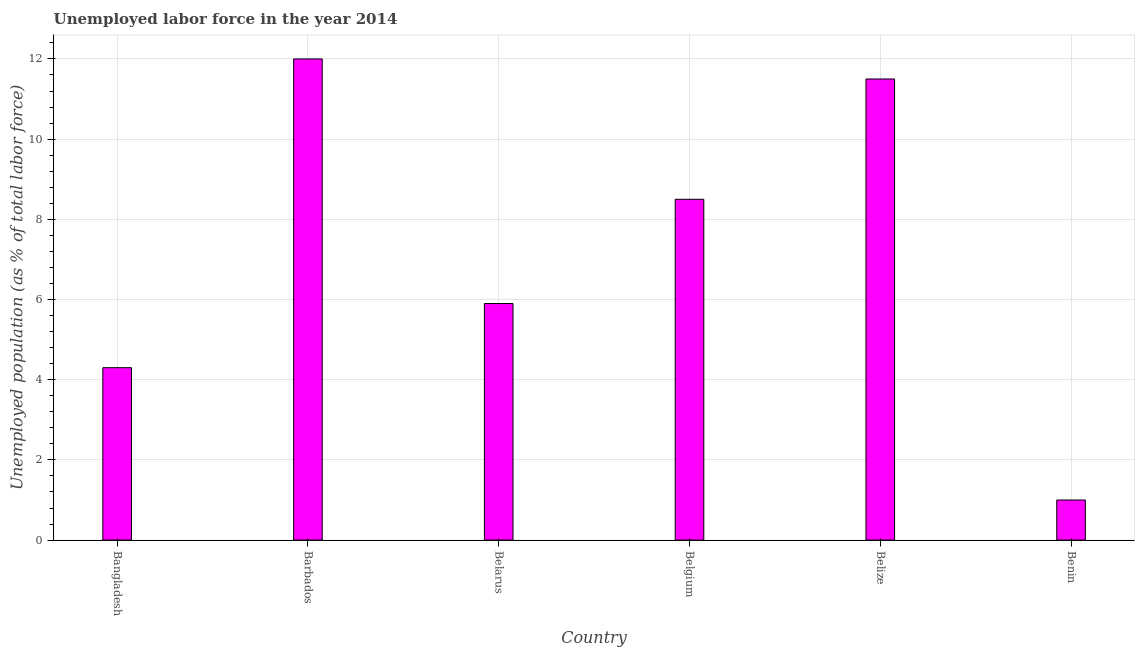Does the graph contain any zero values?
Your response must be concise. No. Does the graph contain grids?
Your answer should be compact. Yes. What is the title of the graph?
Your answer should be very brief. Unemployed labor force in the year 2014. What is the label or title of the X-axis?
Keep it short and to the point. Country. What is the label or title of the Y-axis?
Provide a short and direct response. Unemployed population (as % of total labor force). What is the total unemployed population in Bangladesh?
Provide a succinct answer. 4.3. In which country was the total unemployed population maximum?
Ensure brevity in your answer.  Barbados. In which country was the total unemployed population minimum?
Provide a short and direct response. Benin. What is the sum of the total unemployed population?
Provide a short and direct response. 43.2. What is the median total unemployed population?
Provide a short and direct response. 7.2. In how many countries, is the total unemployed population greater than 11.2 %?
Your answer should be very brief. 2. What is the ratio of the total unemployed population in Belarus to that in Belize?
Offer a very short reply. 0.51. Is the sum of the total unemployed population in Belgium and Belize greater than the maximum total unemployed population across all countries?
Your answer should be compact. Yes. How many countries are there in the graph?
Provide a short and direct response. 6. What is the difference between two consecutive major ticks on the Y-axis?
Give a very brief answer. 2. What is the Unemployed population (as % of total labor force) of Bangladesh?
Ensure brevity in your answer.  4.3. What is the Unemployed population (as % of total labor force) in Belarus?
Make the answer very short. 5.9. What is the Unemployed population (as % of total labor force) in Belize?
Provide a succinct answer. 11.5. What is the Unemployed population (as % of total labor force) in Benin?
Provide a succinct answer. 1. What is the difference between the Unemployed population (as % of total labor force) in Barbados and Belgium?
Give a very brief answer. 3.5. What is the difference between the Unemployed population (as % of total labor force) in Barbados and Benin?
Offer a very short reply. 11. What is the difference between the Unemployed population (as % of total labor force) in Belgium and Belize?
Your answer should be very brief. -3. What is the difference between the Unemployed population (as % of total labor force) in Belgium and Benin?
Your answer should be very brief. 7.5. What is the ratio of the Unemployed population (as % of total labor force) in Bangladesh to that in Barbados?
Provide a succinct answer. 0.36. What is the ratio of the Unemployed population (as % of total labor force) in Bangladesh to that in Belarus?
Provide a succinct answer. 0.73. What is the ratio of the Unemployed population (as % of total labor force) in Bangladesh to that in Belgium?
Provide a succinct answer. 0.51. What is the ratio of the Unemployed population (as % of total labor force) in Bangladesh to that in Belize?
Offer a terse response. 0.37. What is the ratio of the Unemployed population (as % of total labor force) in Barbados to that in Belarus?
Provide a succinct answer. 2.03. What is the ratio of the Unemployed population (as % of total labor force) in Barbados to that in Belgium?
Offer a very short reply. 1.41. What is the ratio of the Unemployed population (as % of total labor force) in Barbados to that in Belize?
Make the answer very short. 1.04. What is the ratio of the Unemployed population (as % of total labor force) in Belarus to that in Belgium?
Provide a short and direct response. 0.69. What is the ratio of the Unemployed population (as % of total labor force) in Belarus to that in Belize?
Your response must be concise. 0.51. What is the ratio of the Unemployed population (as % of total labor force) in Belgium to that in Belize?
Provide a short and direct response. 0.74. What is the ratio of the Unemployed population (as % of total labor force) in Belize to that in Benin?
Offer a terse response. 11.5. 